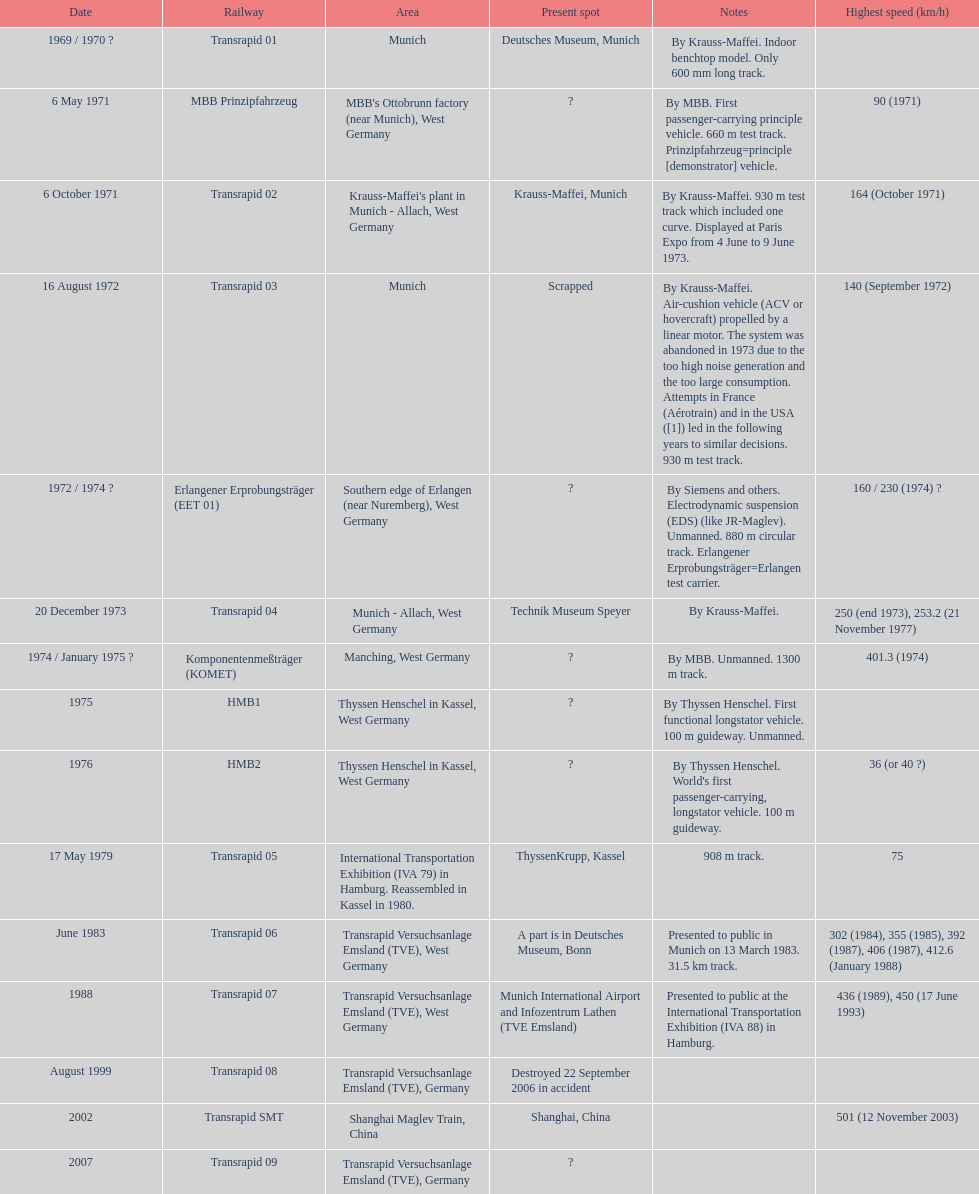How many trains other than the transrapid 07 can go faster than 450km/h? 1. 